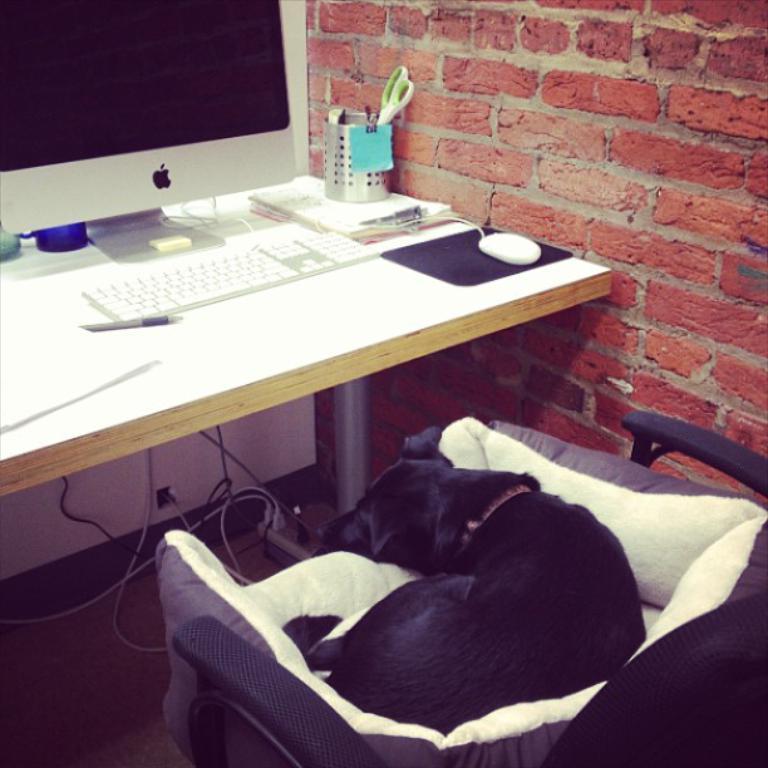Can you describe this image briefly? This picture shows a monitor,a keyboard and a mouse and we see a pen stand and a scissors and a paper on the table. we see dog seated on the chair and we see a brick wall on the side 